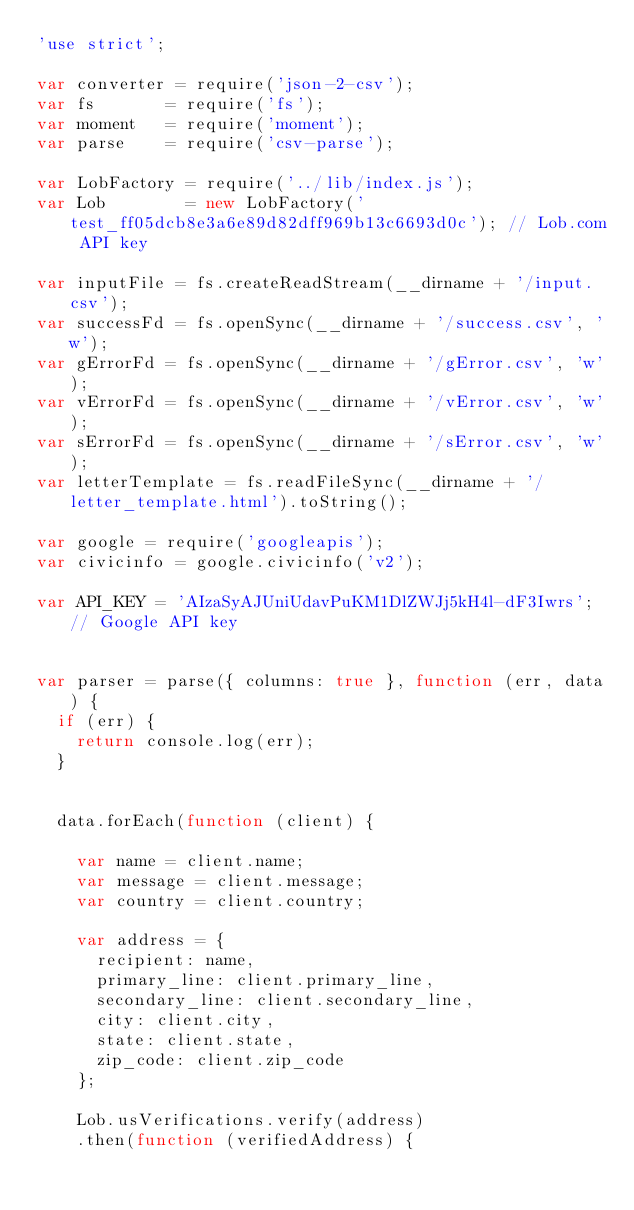Convert code to text. <code><loc_0><loc_0><loc_500><loc_500><_JavaScript_>'use strict';

var converter = require('json-2-csv');
var fs       = require('fs');
var moment   = require('moment');
var parse    = require('csv-parse');

var LobFactory = require('../lib/index.js');
var Lob        = new LobFactory('test_ff05dcb8e3a6e89d82dff969b13c6693d0c'); // Lob.com API key

var inputFile = fs.createReadStream(__dirname + '/input.csv');
var successFd = fs.openSync(__dirname + '/success.csv', 'w');
var gErrorFd = fs.openSync(__dirname + '/gError.csv', 'w');
var vErrorFd = fs.openSync(__dirname + '/vError.csv', 'w');
var sErrorFd = fs.openSync(__dirname + '/sError.csv', 'w');
var letterTemplate = fs.readFileSync(__dirname + '/letter_template.html').toString();

var google = require('googleapis');
var civicinfo = google.civicinfo('v2');

var API_KEY = 'AIzaSyAJUniUdavPuKM1DlZWJj5kH4l-dF3Iwrs'; // Google API key


var parser = parse({ columns: true }, function (err, data) {
  if (err) {
    return console.log(err);
  }
  
  
  data.forEach(function (client) {
  
    var name = client.name;
    var message = client.message;
    var country = client.country;

    var address = {
      recipient: name,
      primary_line: client.primary_line,
      secondary_line: client.secondary_line,
      city: client.city,
      state: client.state,
      zip_code: client.zip_code
    };
  
    Lob.usVerifications.verify(address)
    .then(function (verifiedAddress) {
        </code> 